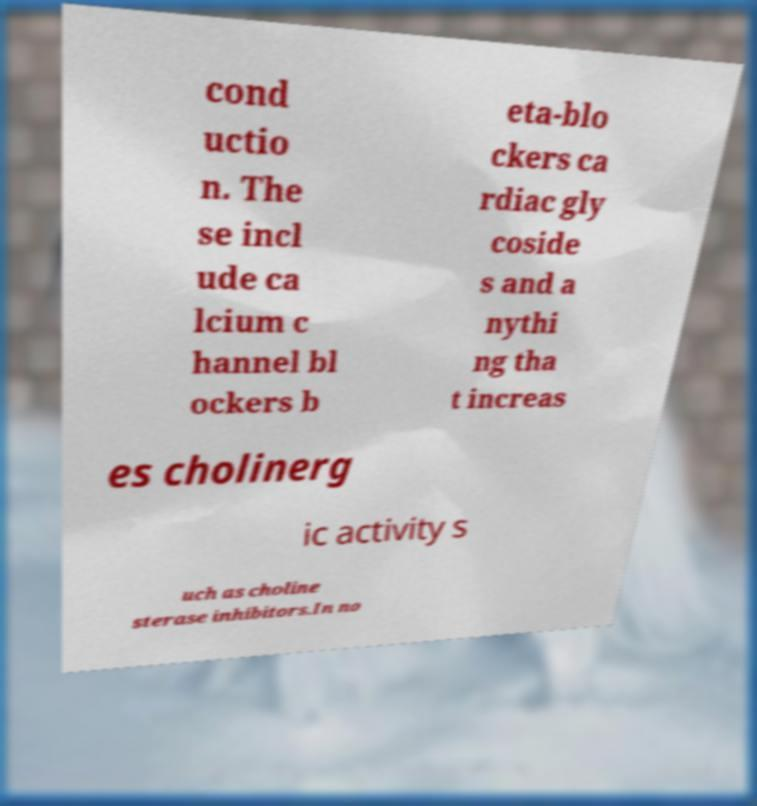What messages or text are displayed in this image? I need them in a readable, typed format. cond uctio n. The se incl ude ca lcium c hannel bl ockers b eta-blo ckers ca rdiac gly coside s and a nythi ng tha t increas es cholinerg ic activity s uch as choline sterase inhibitors.In no 